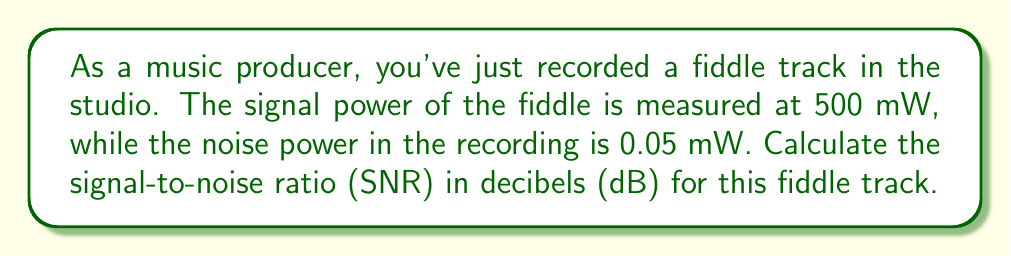What is the answer to this math problem? To solve this problem, we'll follow these steps:

1. Recall the formula for Signal-to-Noise Ratio (SNR) in decibels:

   $$SNR_{dB} = 10 \log_{10}\left(\frac{P_{signal}}{P_{noise}}\right)$$

   Where $P_{signal}$ is the signal power and $P_{noise}$ is the noise power.

2. Insert the given values into the formula:
   
   $P_{signal} = 500 \text{ mW}$
   $P_{noise} = 0.05 \text{ mW}$

   $$SNR_{dB} = 10 \log_{10}\left(\frac{500}{0.05}\right)$$

3. Simplify the fraction inside the logarithm:

   $$SNR_{dB} = 10 \log_{10}(10000)$$

4. Use the logarithm property $\log_a(x^n) = n\log_a(x)$:

   $$SNR_{dB} = 10 \cdot 4 \log_{10}(10)$$

5. Recall that $\log_{10}(10) = 1$:

   $$SNR_{dB} = 10 \cdot 4 \cdot 1 = 40$$

Therefore, the signal-to-noise ratio of the recorded fiddle track is 40 dB.
Answer: 40 dB 